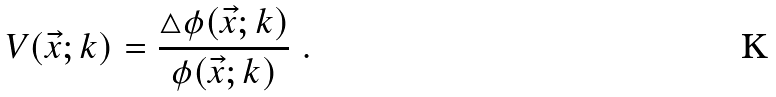<formula> <loc_0><loc_0><loc_500><loc_500>V ( \vec { x } ; k ) = \frac { \triangle \phi ( \vec { x } ; k ) } { \phi ( \vec { x } ; k ) } \ .</formula> 